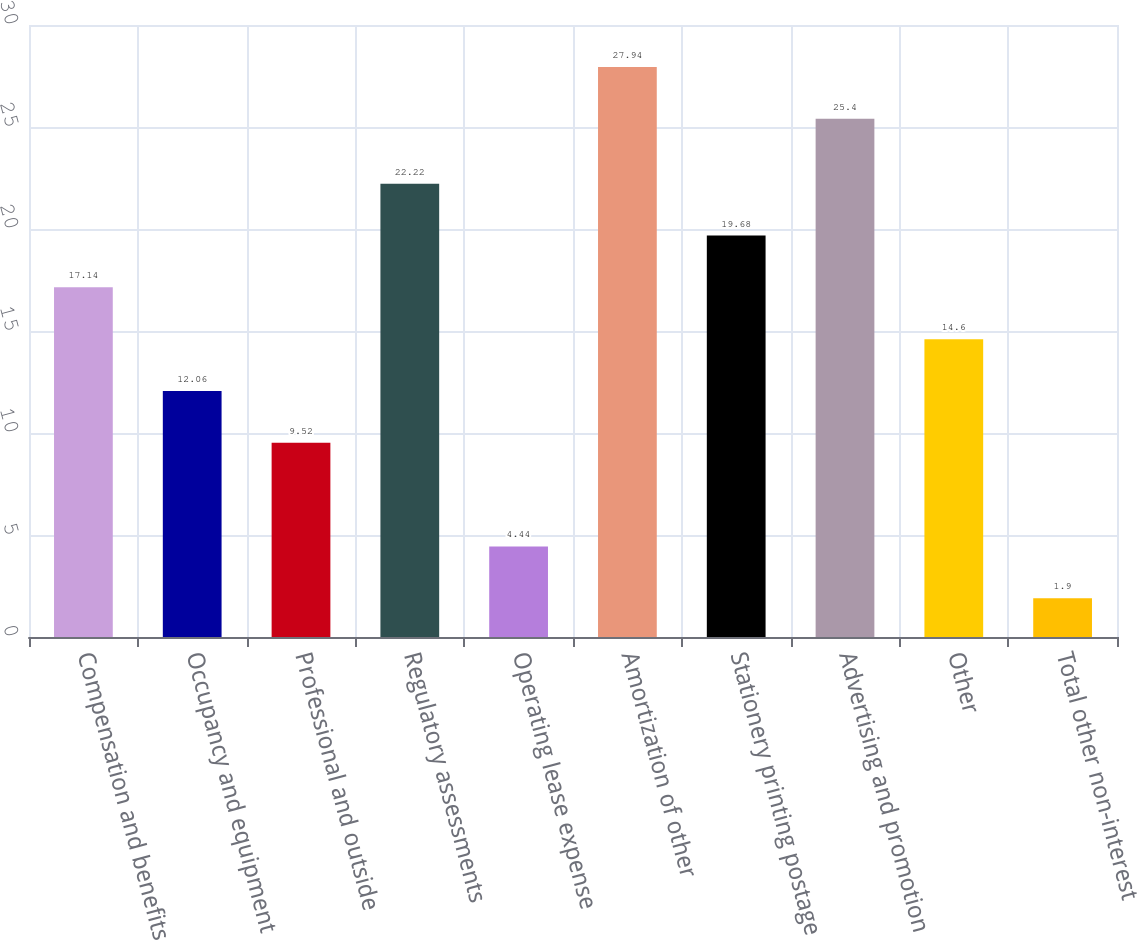Convert chart. <chart><loc_0><loc_0><loc_500><loc_500><bar_chart><fcel>Compensation and benefits<fcel>Occupancy and equipment<fcel>Professional and outside<fcel>Regulatory assessments<fcel>Operating lease expense<fcel>Amortization of other<fcel>Stationery printing postage<fcel>Advertising and promotion<fcel>Other<fcel>Total other non-interest<nl><fcel>17.14<fcel>12.06<fcel>9.52<fcel>22.22<fcel>4.44<fcel>27.94<fcel>19.68<fcel>25.4<fcel>14.6<fcel>1.9<nl></chart> 